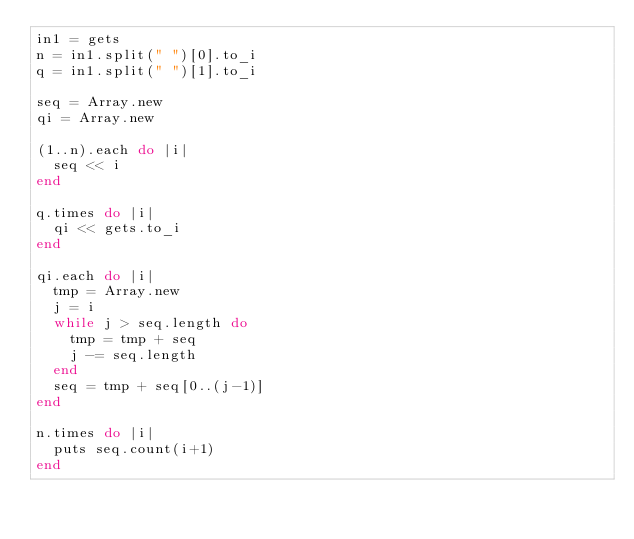<code> <loc_0><loc_0><loc_500><loc_500><_Ruby_>in1 = gets
n = in1.split(" ")[0].to_i
q = in1.split(" ")[1].to_i

seq = Array.new
qi = Array.new

(1..n).each do |i|
	seq << i
end

q.times do |i|
	qi << gets.to_i
end

qi.each do |i|
	tmp = Array.new
	j = i
	while j > seq.length do
		tmp = tmp + seq
		j -= seq.length
	end
	seq = tmp + seq[0..(j-1)]
end

n.times do |i|
	puts seq.count(i+1)
end</code> 